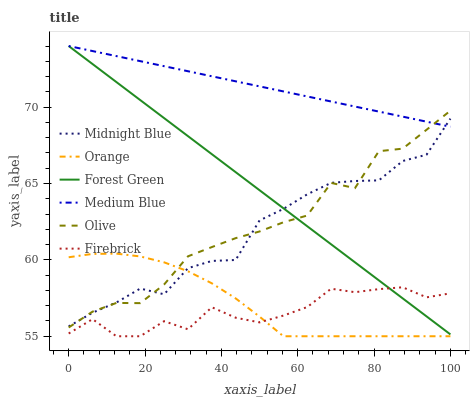Does Firebrick have the minimum area under the curve?
Answer yes or no. Yes. Does Medium Blue have the maximum area under the curve?
Answer yes or no. Yes. Does Medium Blue have the minimum area under the curve?
Answer yes or no. No. Does Firebrick have the maximum area under the curve?
Answer yes or no. No. Is Medium Blue the smoothest?
Answer yes or no. Yes. Is Firebrick the roughest?
Answer yes or no. Yes. Is Firebrick the smoothest?
Answer yes or no. No. Is Medium Blue the roughest?
Answer yes or no. No. Does Firebrick have the lowest value?
Answer yes or no. Yes. Does Medium Blue have the lowest value?
Answer yes or no. No. Does Forest Green have the highest value?
Answer yes or no. Yes. Does Firebrick have the highest value?
Answer yes or no. No. Is Orange less than Forest Green?
Answer yes or no. Yes. Is Midnight Blue greater than Firebrick?
Answer yes or no. Yes. Does Orange intersect Firebrick?
Answer yes or no. Yes. Is Orange less than Firebrick?
Answer yes or no. No. Is Orange greater than Firebrick?
Answer yes or no. No. Does Orange intersect Forest Green?
Answer yes or no. No. 